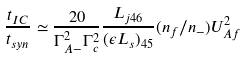<formula> <loc_0><loc_0><loc_500><loc_500>\frac { t _ { I C } } { t _ { s y n } } \simeq \frac { 2 0 } { \Gamma _ { A - } ^ { 2 } \Gamma _ { c } ^ { 2 } } \frac { L _ { j 4 6 } } { ( \epsilon L _ { s } ) _ { 4 5 } } ( n _ { f } / n _ { - } ) U ^ { 2 } _ { A f }</formula> 